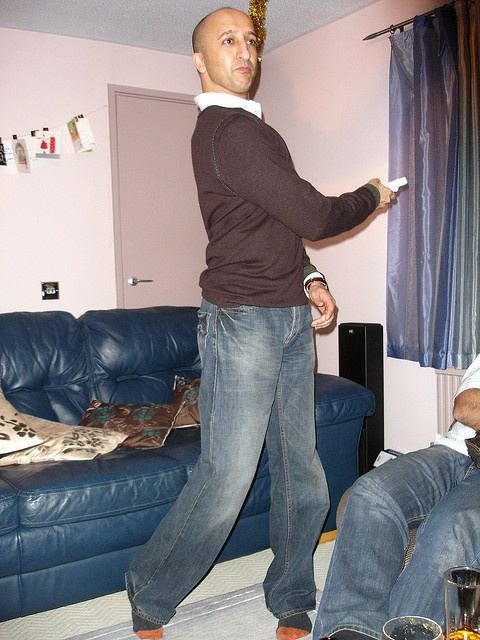Describe the objects in this image and their specific colors. I can see people in gray, darkgray, maroon, and blue tones, couch in gray, darkblue, blue, and black tones, people in gray and darkgray tones, cup in gray, black, darkgray, and maroon tones, and remote in gray, white, and darkgray tones in this image. 